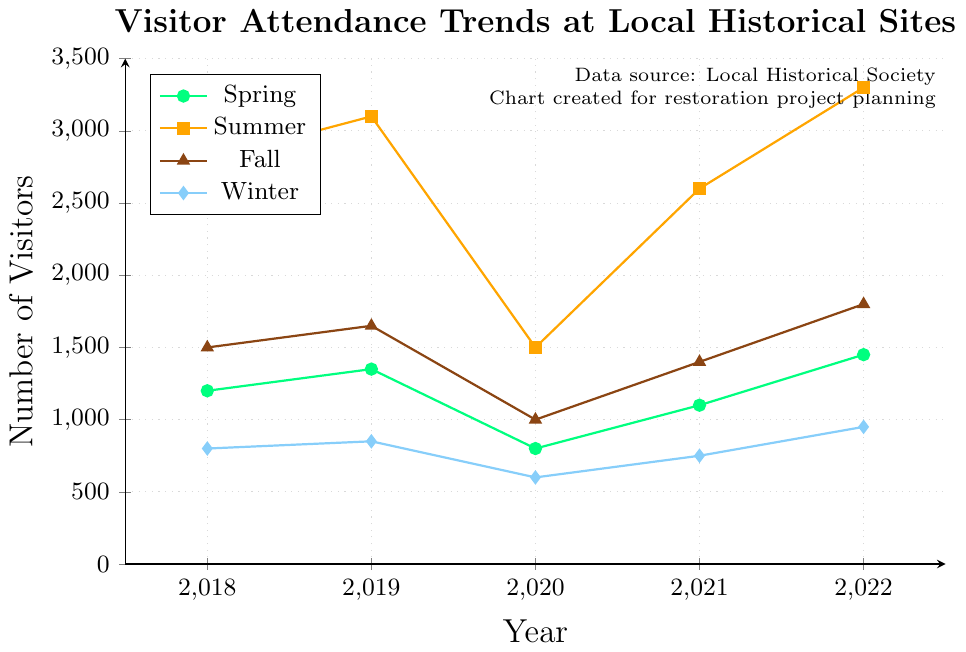What season had the highest visitor attendance in 2019? Look at the 2019 data points and compare the values for each season. Summer had the highest value of 3100.
Answer: Summer Which year recorded the lowest winter visitor attendance? Compare the winter visitor attendance values for each year. The lowest value is 600 in 2020.
Answer: 2020 What is the average number of visitors in Fall across all years? Add up the fall attendance for all years and divide by the number of years (1500+1650+1000+1400+1800)/5 = 1470.
Answer: 1470 Did any season see a decline in visitors from 2018 to 2019? Compare the attendance in 2018 and 2019 for each season. None of the seasons saw a decline; all saw an increase.
Answer: No Which seasons had an increase in visitors from 2021 to 2022? Compare the numbers between 2021 and 2022 for each season. Spring (1100 to 1450), Summer (2600 to 3300), Fall (1400 to 1800), Winter (750 to 950), all seasons saw increases.
Answer: Spring, Summer, Fall, Winter What was the most significant drop in visitor attendance between two consecutive years for any season? Calculate the year-over-year differences for each season. The biggest drop is in Summer from 2019 to 2020, where the attendance drops from 3100 to 1500, a difference of 1600.
Answer: Summer (2019 to 2020) How does the attendance trend for Winter compare to the attendance trend for Fall from 2018 to 2022? Compare the trend lines for Winter and Fall. Both have increased overall, but Fall shows larger increases.
Answer: Fall shows larger increases What was the total number of visitors in Spring and Summer in 2018? Add the Spring and Summer attendance for 2018: 1200 (Spring) + 2800 (Summer) = 4000.
Answer: 4000 Which season had the least variation in visitor attendance over the years? Compare the range of values for each season. Winter has the smallest range (950-600 = 350).
Answer: Winter In which season did visitor attendance return to pre-2020 levels first? Compare pre-2020 levels to post-2020 levels. Summer returned to pre-2020 levels in 2021 (2600 vs 3100).
Answer: Summer 